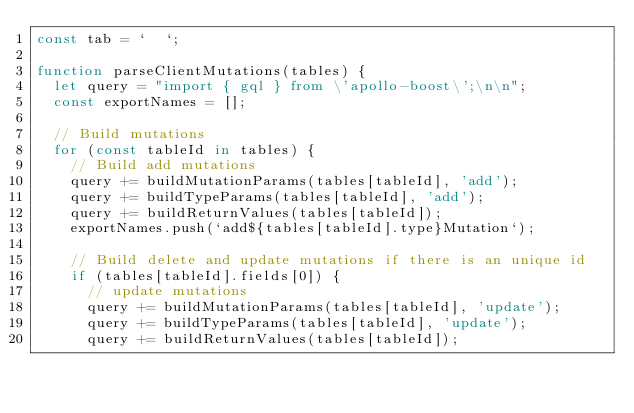Convert code to text. <code><loc_0><loc_0><loc_500><loc_500><_JavaScript_>const tab = `  `;

function parseClientMutations(tables) {
  let query = "import { gql } from \'apollo-boost\';\n\n";
  const exportNames = [];

  // Build mutations
  for (const tableId in tables) {
    // Build add mutations
    query += buildMutationParams(tables[tableId], 'add');
    query += buildTypeParams(tables[tableId], 'add');
    query += buildReturnValues(tables[tableId]);
    exportNames.push(`add${tables[tableId].type}Mutation`);

    // Build delete and update mutations if there is an unique id
    if (tables[tableId].fields[0]) {
      // update mutations
      query += buildMutationParams(tables[tableId], 'update');
      query += buildTypeParams(tables[tableId], 'update');
      query += buildReturnValues(tables[tableId]);</code> 